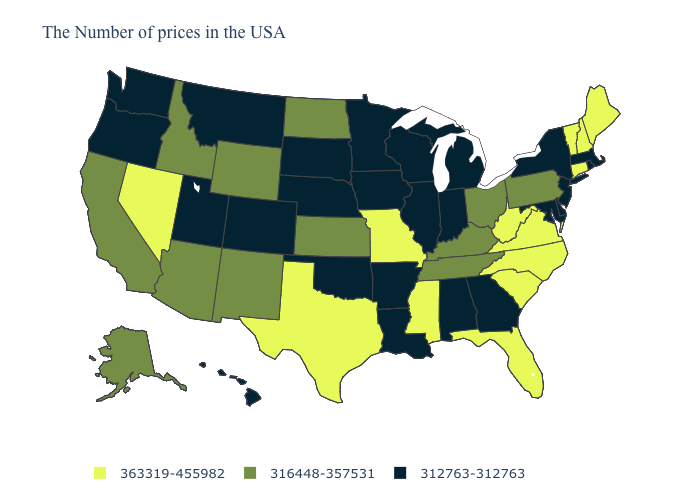How many symbols are there in the legend?
Concise answer only. 3. Which states have the highest value in the USA?
Keep it brief. Maine, New Hampshire, Vermont, Connecticut, Virginia, North Carolina, South Carolina, West Virginia, Florida, Mississippi, Missouri, Texas, Nevada. Among the states that border Wisconsin , which have the highest value?
Answer briefly. Michigan, Illinois, Minnesota, Iowa. Does the first symbol in the legend represent the smallest category?
Write a very short answer. No. Among the states that border Wyoming , which have the highest value?
Be succinct. Idaho. Which states have the lowest value in the USA?
Quick response, please. Massachusetts, Rhode Island, New York, New Jersey, Delaware, Maryland, Georgia, Michigan, Indiana, Alabama, Wisconsin, Illinois, Louisiana, Arkansas, Minnesota, Iowa, Nebraska, Oklahoma, South Dakota, Colorado, Utah, Montana, Washington, Oregon, Hawaii. Which states have the lowest value in the USA?
Give a very brief answer. Massachusetts, Rhode Island, New York, New Jersey, Delaware, Maryland, Georgia, Michigan, Indiana, Alabama, Wisconsin, Illinois, Louisiana, Arkansas, Minnesota, Iowa, Nebraska, Oklahoma, South Dakota, Colorado, Utah, Montana, Washington, Oregon, Hawaii. Among the states that border New Jersey , does Delaware have the highest value?
Concise answer only. No. What is the value of Massachusetts?
Quick response, please. 312763-312763. Does the first symbol in the legend represent the smallest category?
Short answer required. No. Does Colorado have the same value as Idaho?
Short answer required. No. What is the lowest value in the Northeast?
Give a very brief answer. 312763-312763. Name the states that have a value in the range 363319-455982?
Answer briefly. Maine, New Hampshire, Vermont, Connecticut, Virginia, North Carolina, South Carolina, West Virginia, Florida, Mississippi, Missouri, Texas, Nevada. What is the highest value in states that border Georgia?
Give a very brief answer. 363319-455982. What is the value of Oklahoma?
Give a very brief answer. 312763-312763. 